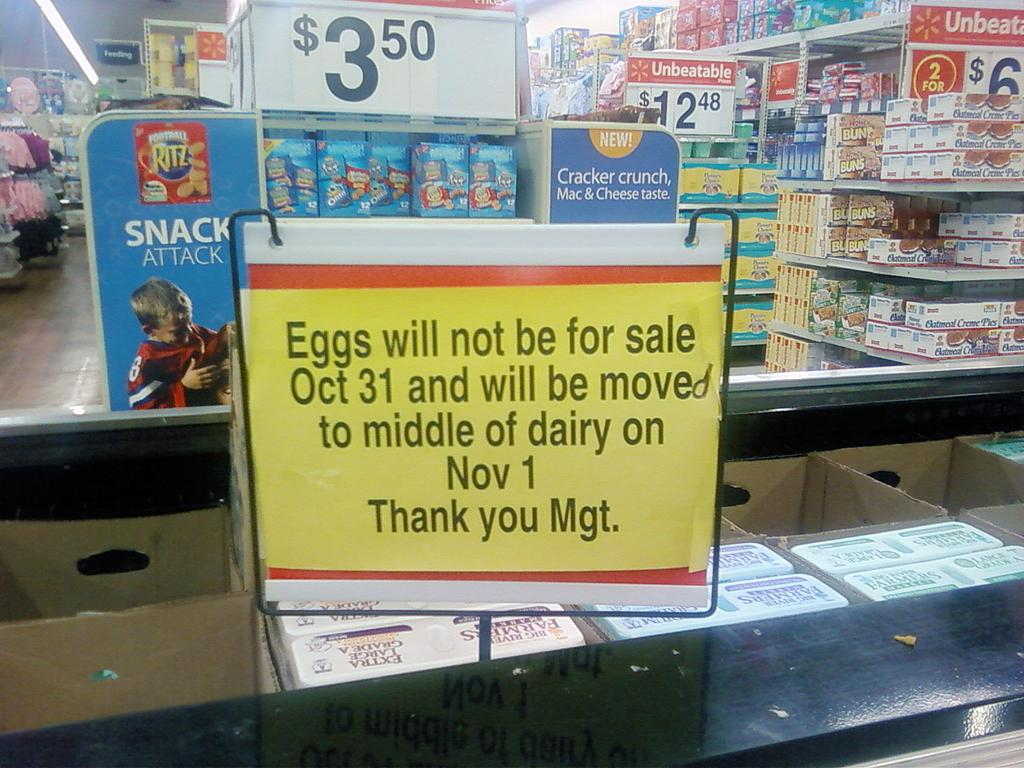<image>
Describe the image concisely. A grocery store with a sign that reads Eggs will not be for sale Oct 31. 